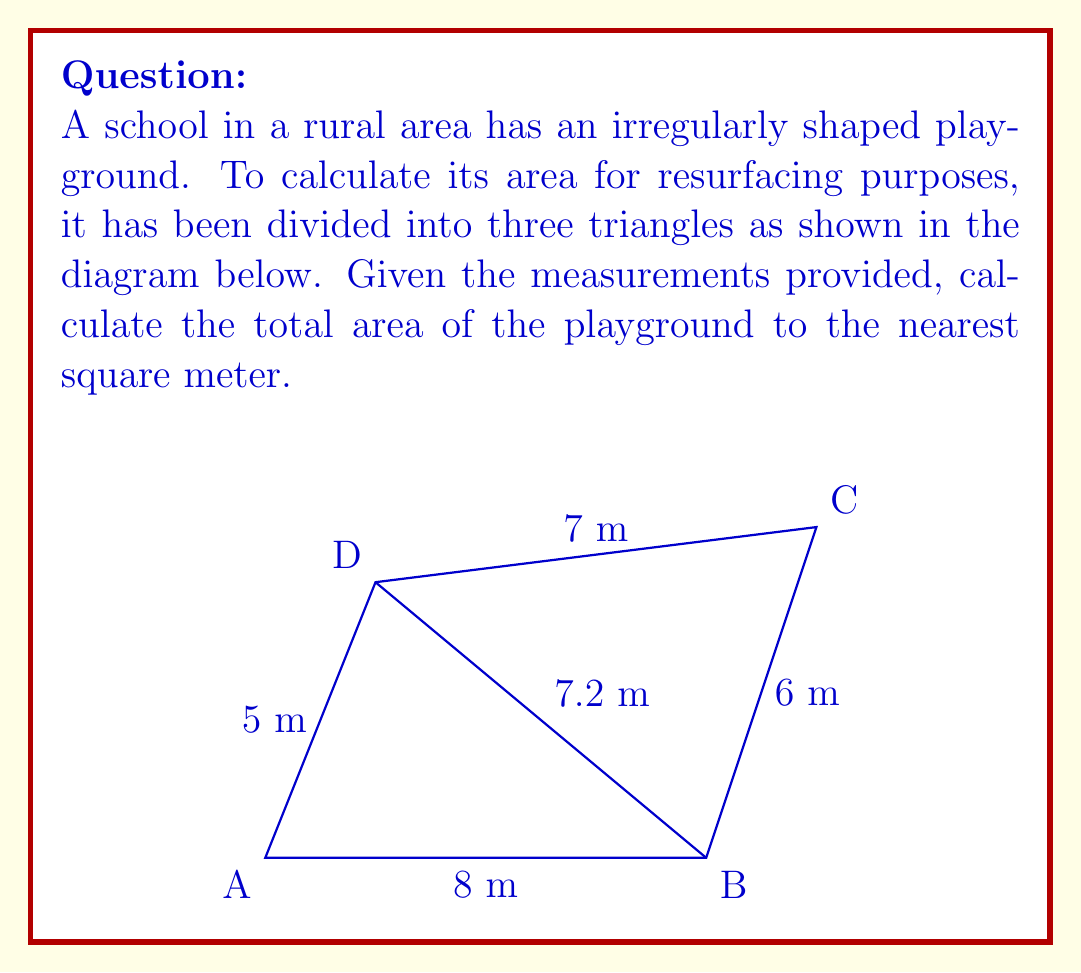Can you solve this math problem? To find the area of the irregularly shaped playground, we'll use the triangulation method and calculate the areas of the three triangles separately.

1. Triangle ABD:
   Base = 8 m, Height = 5 m
   Area of ABD = $\frac{1}{2} \times 8 \times 5 = 20$ m²

2. Triangle BCD:
   We can use Heron's formula to calculate this area.
   Semi-perimeter, $s = \frac{6 + 7 + 7.2}{2} = 10.1$ m
   Area of BCD = $\sqrt{s(s-a)(s-b)(s-c)}$
   where $a = 6$, $b = 7$, and $c = 7.2$
   
   Area of BCD = $\sqrt{10.1(10.1-6)(10.1-7)(10.1-7.2)}$
                = $\sqrt{10.1 \times 4.1 \times 3.1 \times 2.9}$
                ≈ 20.96 m²

3. Triangle BDC:
   Base = 7.2 m, Height can be calculated using the Pythagorean theorem:
   $h^2 + 6^2 = 7^2$
   $h^2 = 7^2 - 6^2 = 13$
   $h = \sqrt{13}$ ≈ 3.61 m
   
   Area of BDC = $\frac{1}{2} \times 7.2 \times 3.61 ≈ 12.996$ m²

Total Area = Area of ABD + Area of BCD + Area of BDC
           ≈ 20 + 20.96 + 12.996
           ≈ 53.956 m²

Rounding to the nearest square meter: 54 m²
Answer: 54 m² 